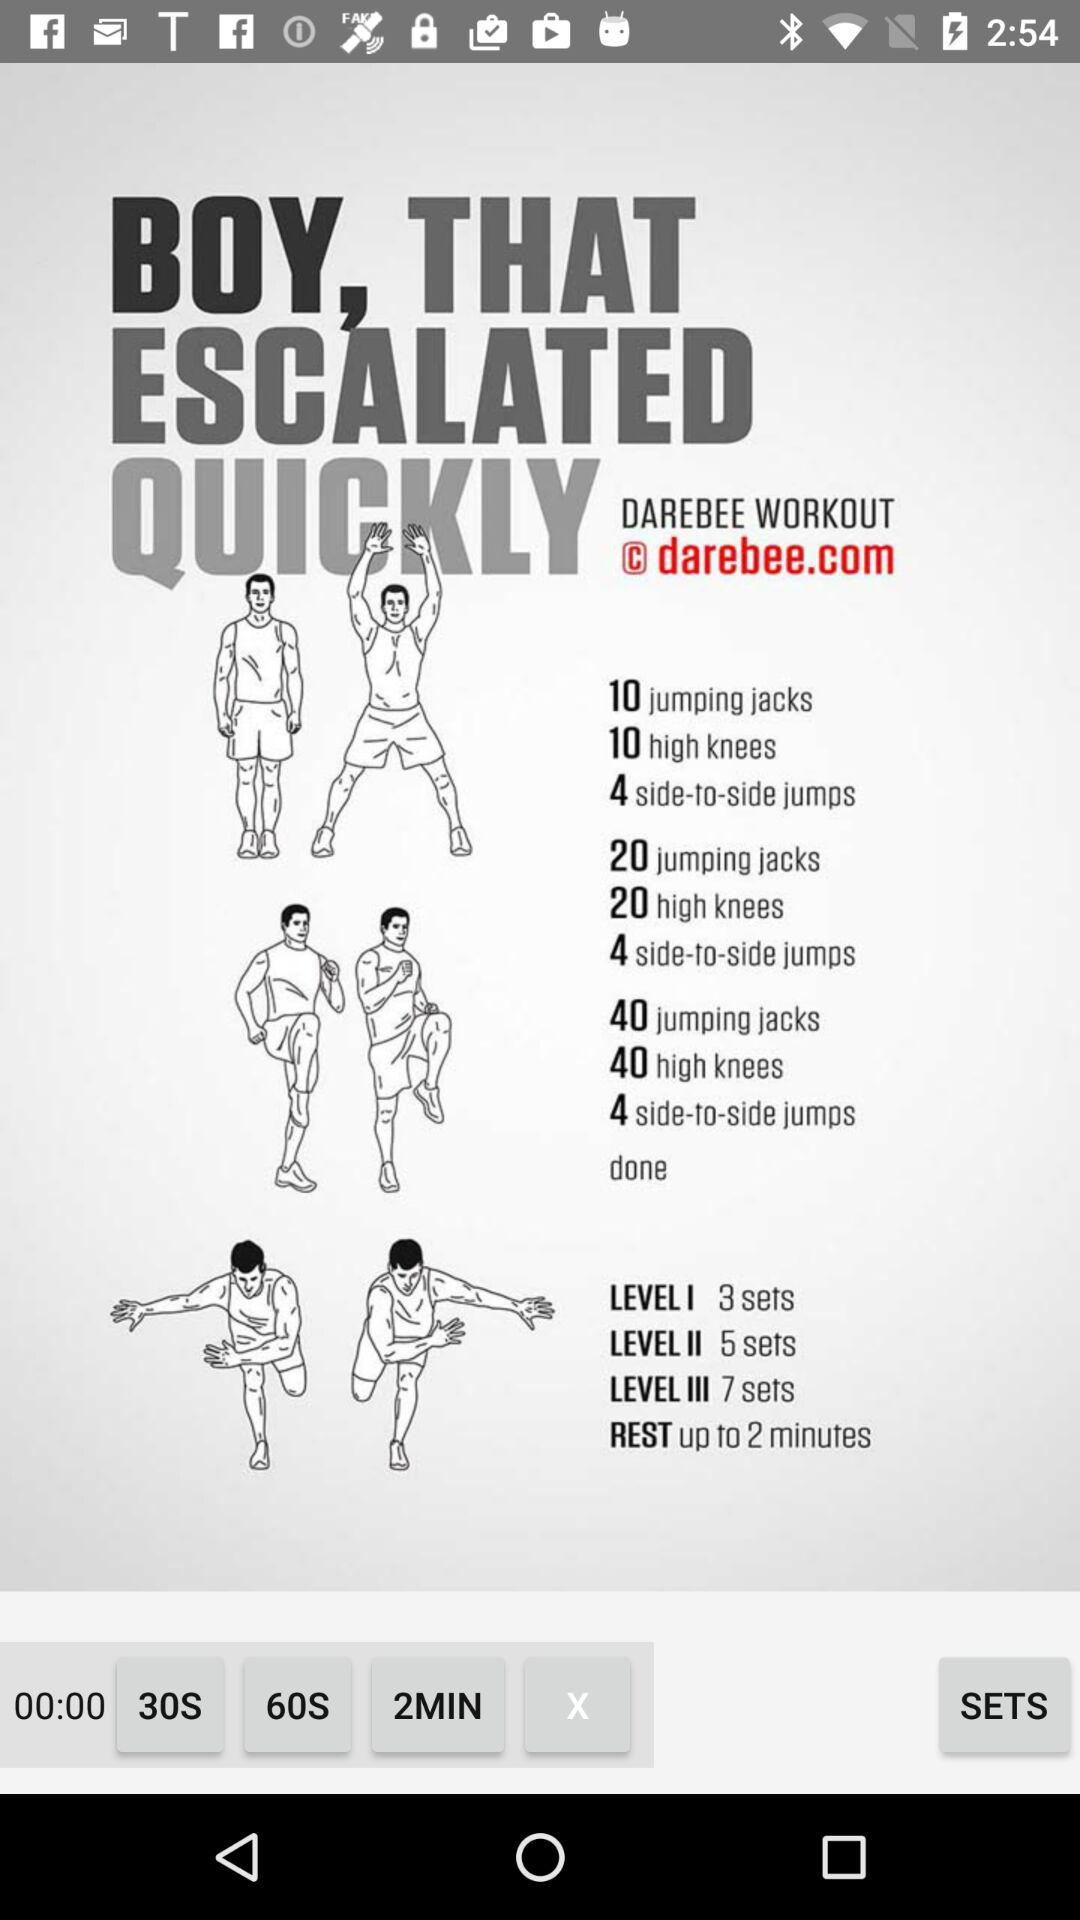How many sets does Level 1 include? Level 1 includes 3 sets. 